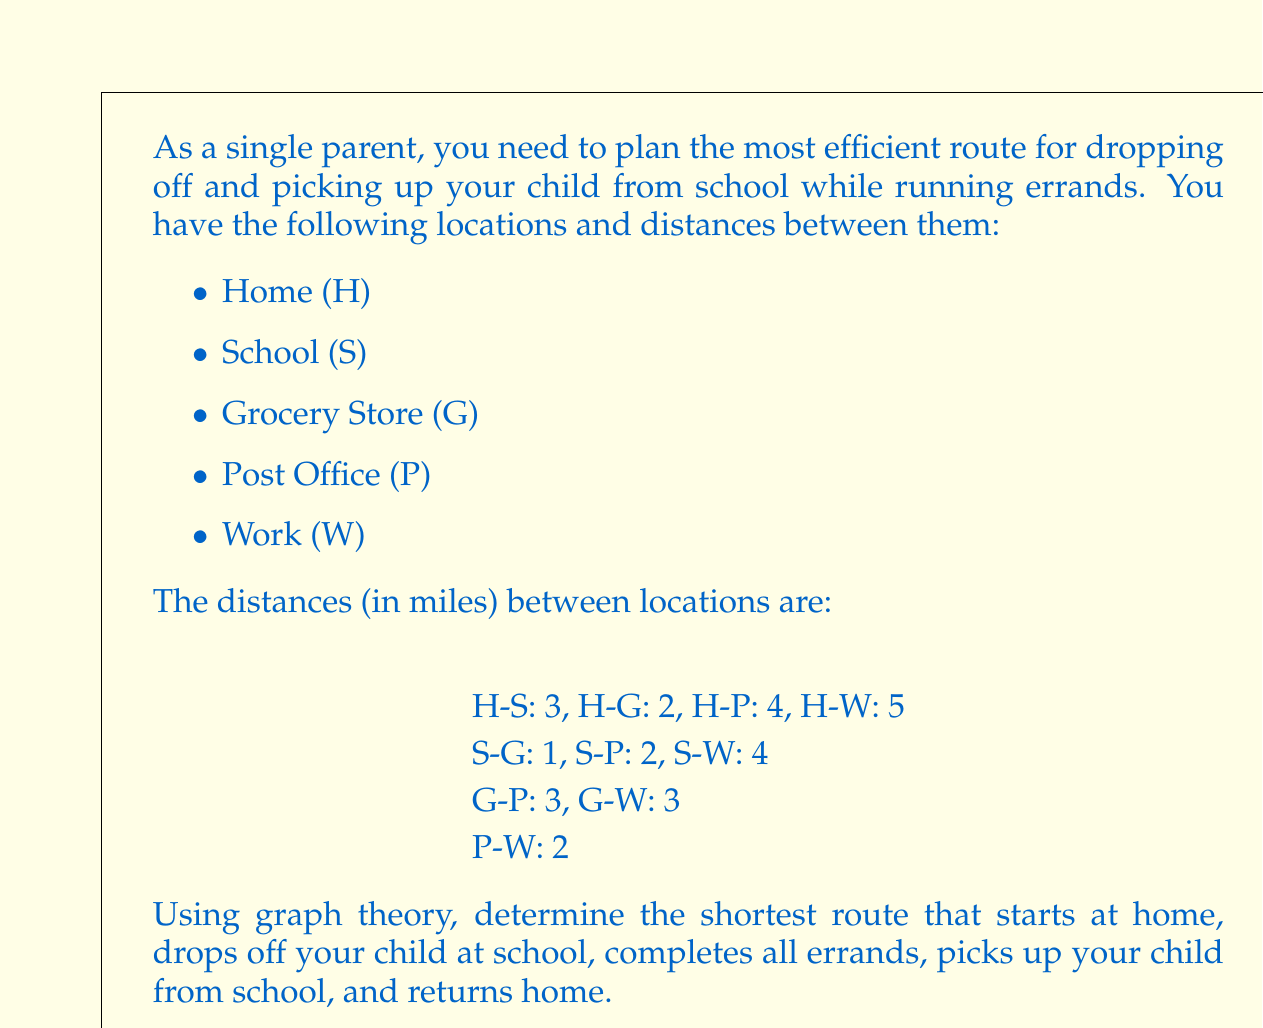Can you solve this math problem? To solve this problem, we can use graph theory and the concept of finding the shortest path in a weighted graph. Here's a step-by-step approach:

1. Represent the problem as a graph:
   [asy]
   import graph;
   size(200);
   
   void drawNode(pair p, string s) {
     fill(circle(p, 0.3), white);
     draw(circle(p, 0.3));
     label(s, p);
   }
   
   pair H = (0,0), S = (2,2), G = (4,0), P = (4,4), W = (6,2);
   
   drawNode(H, "H");
   drawNode(S, "S");
   drawNode(G, "G");
   drawNode(P, "P");
   drawNode(W, "W");
   
   draw(H--S, L="3");
   draw(H--G, L="2");
   draw(H--P, L="4");
   draw(H--W, L="5");
   draw(S--G, L="1");
   draw(S--P, L="2");
   draw(S--W, L="4");
   draw(G--P, L="3");
   draw(G--W, L="3");
   draw(P--W, L="2");
   [/asy]

2. The route must follow this pattern: H → S → (G, P, W in some order) → S → H

3. To find the optimal route, we need to determine the best order to visit G, P, and W between the two school visits.

4. Calculate the total distance for all possible permutations:
   a) H → S → G → P → W → S → H
      Distance = 3 + 1 + 3 + 2 + 4 + 3 = 16 miles
   
   b) H → S → G → W → P → S → H
      Distance = 3 + 1 + 3 + 2 + 2 + 3 = 14 miles
   
   c) H → S → P → G → W → S → H
      Distance = 3 + 2 + 3 + 3 + 4 + 3 = 18 miles
   
   d) H → S → P → W → G → S → H
      Distance = 3 + 2 + 2 + 3 + 1 + 3 = 14 miles
   
   e) H → S → W → G → P → S → H
      Distance = 3 + 4 + 3 + 3 + 2 + 3 = 18 miles
   
   f) H → S → W → P → G → S → H
      Distance = 3 + 4 + 2 + 3 + 1 + 3 = 16 miles

5. The shortest routes are b) and d), both with a total distance of 14 miles.
Answer: The most efficient route is either:
H → S → G → W → P → S → H
or
H → S → P → W → G → S → H
Both routes have a total distance of 14 miles. 